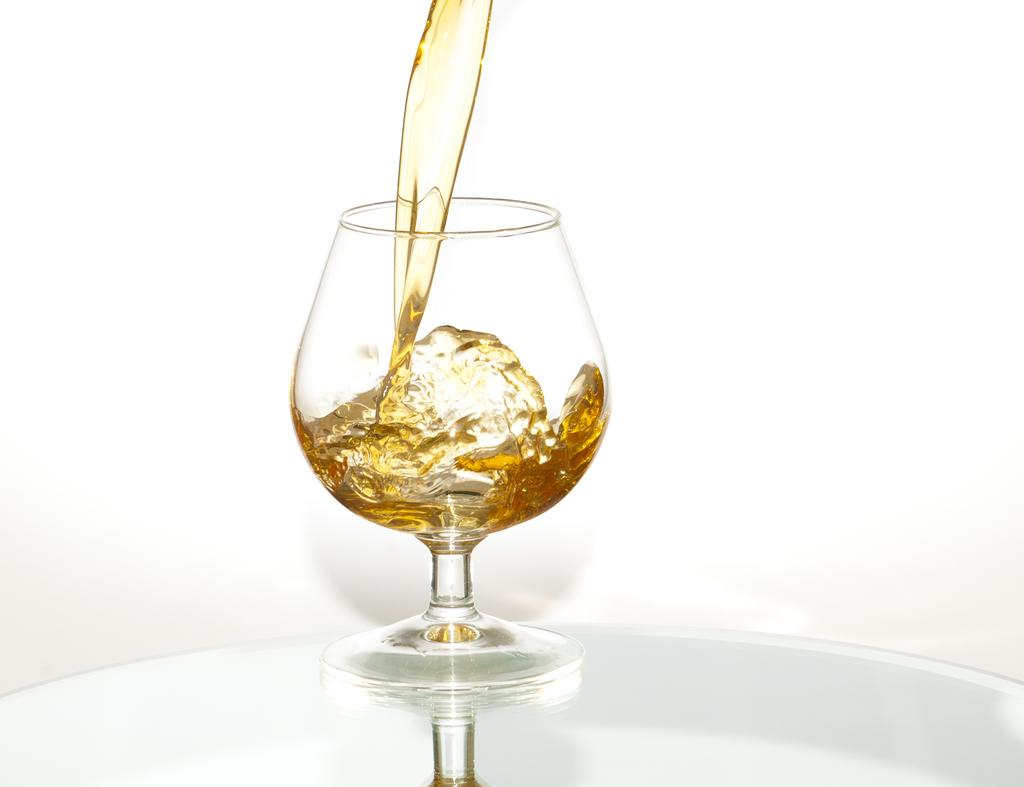What is located at the bottom of the image? There is a table at the bottom of the image. What object is on the table? There is a glass on the table. What is inside the glass? The glass contains liquid. What type of suit is hanging on the floor in the image? There is no suit or floor present in the image; it only features a table with a glass containing liquid. 